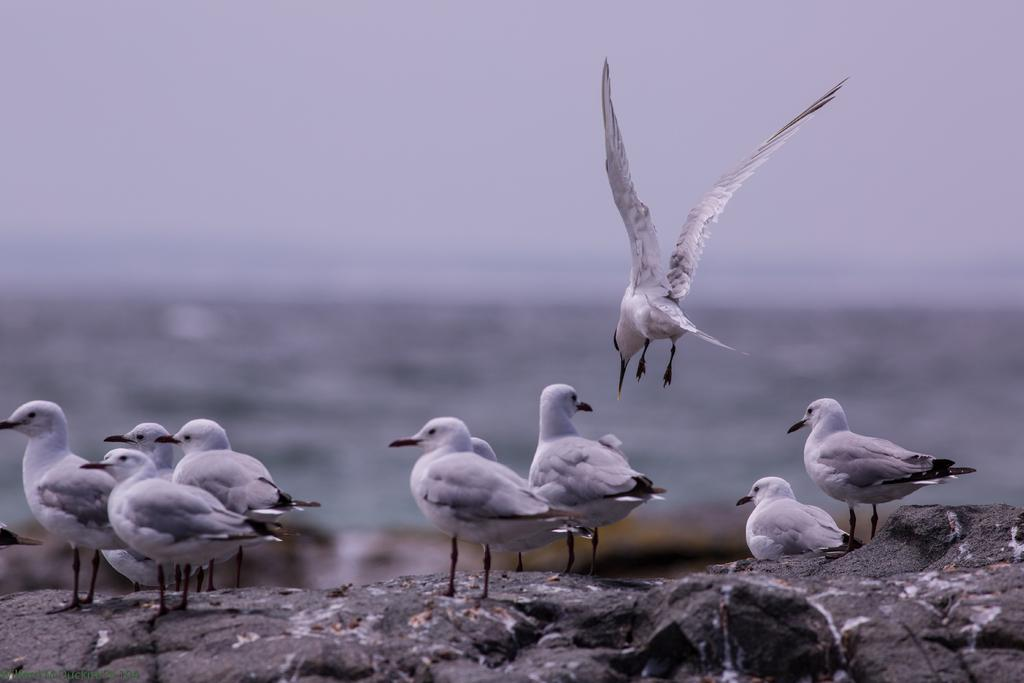What type of animals can be seen in the image? There are birds in the image. Where are the birds located in the image? The birds are sitting on rocks. Can you describe the background of the image? The background of the image is blurred. How many giants can be seen interacting with the birds in the image? There are no giants present in the image; it features birds sitting on rocks with a blurred background. Is there a swing visible in the image? There is no swing present in the image. 